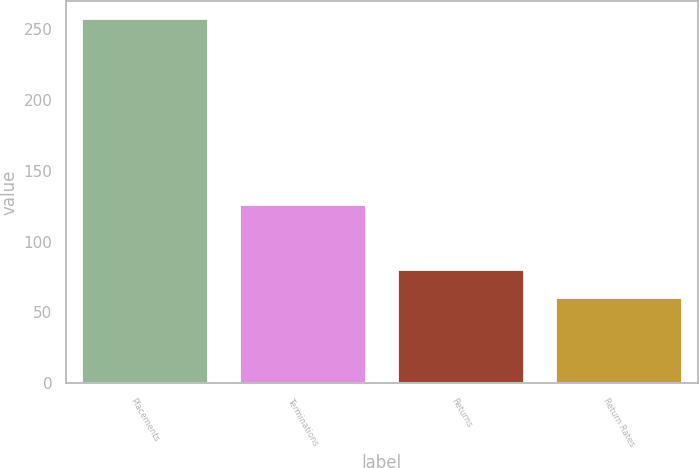Convert chart to OTSL. <chart><loc_0><loc_0><loc_500><loc_500><bar_chart><fcel>Placements<fcel>Terminations<fcel>Returns<fcel>Return Rates<nl><fcel>257<fcel>126<fcel>79.7<fcel>60<nl></chart> 